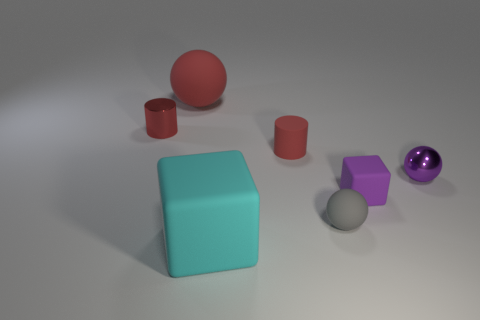Add 2 purple things. How many objects exist? 9 Subtract all cubes. How many objects are left? 5 Subtract 0 yellow spheres. How many objects are left? 7 Subtract all red metal cylinders. Subtract all gray metal cylinders. How many objects are left? 6 Add 2 matte cubes. How many matte cubes are left? 4 Add 5 rubber things. How many rubber things exist? 10 